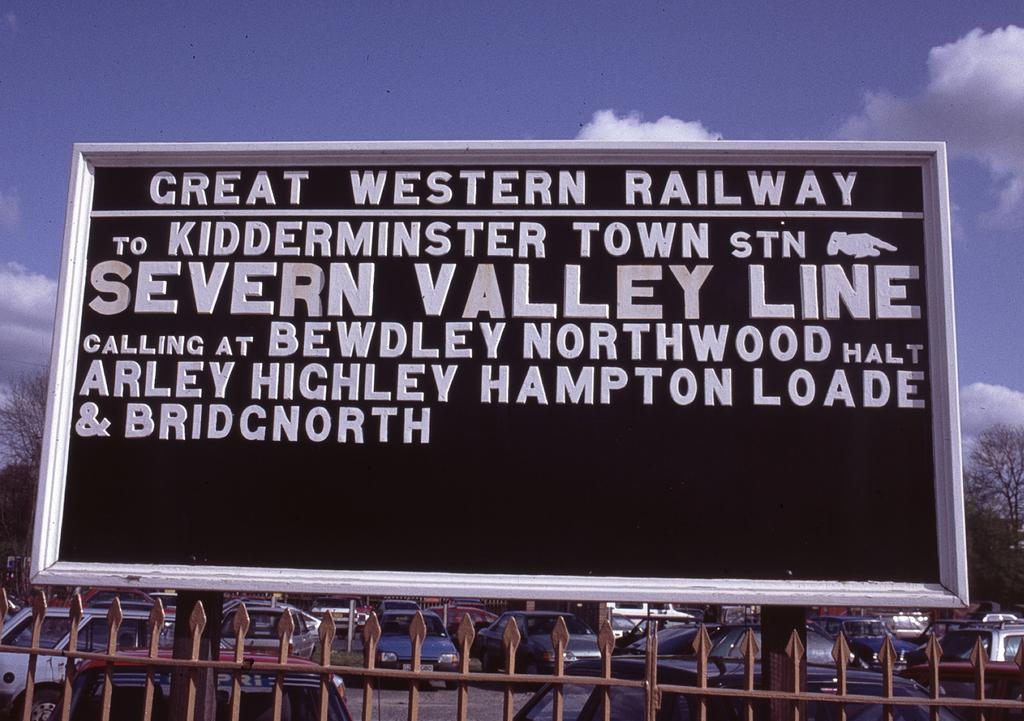Provide a one-sentence caption for the provided image. A sign for a railroad called Great Western Railway, the go to Kidderminster town station. 